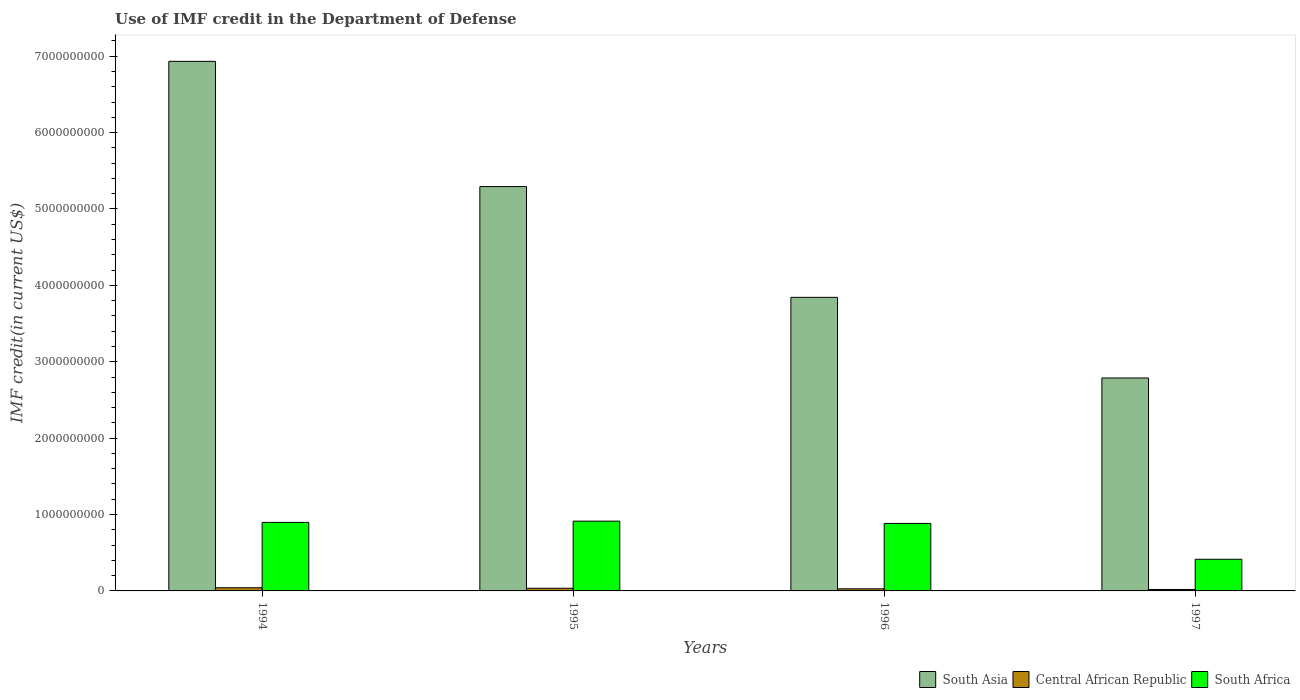How many groups of bars are there?
Make the answer very short. 4. Are the number of bars on each tick of the X-axis equal?
Your response must be concise. Yes. How many bars are there on the 2nd tick from the left?
Ensure brevity in your answer.  3. What is the IMF credit in the Department of Defense in Central African Republic in 1994?
Give a very brief answer. 4.14e+07. Across all years, what is the maximum IMF credit in the Department of Defense in South Africa?
Give a very brief answer. 9.13e+08. Across all years, what is the minimum IMF credit in the Department of Defense in Central African Republic?
Give a very brief answer. 1.86e+07. In which year was the IMF credit in the Department of Defense in South Asia maximum?
Offer a very short reply. 1994. In which year was the IMF credit in the Department of Defense in Central African Republic minimum?
Make the answer very short. 1997. What is the total IMF credit in the Department of Defense in South Asia in the graph?
Your answer should be compact. 1.89e+1. What is the difference between the IMF credit in the Department of Defense in Central African Republic in 1996 and that in 1997?
Keep it short and to the point. 9.02e+06. What is the difference between the IMF credit in the Department of Defense in Central African Republic in 1994 and the IMF credit in the Department of Defense in South Asia in 1995?
Make the answer very short. -5.25e+09. What is the average IMF credit in the Department of Defense in South Africa per year?
Your answer should be compact. 7.77e+08. In the year 1995, what is the difference between the IMF credit in the Department of Defense in Central African Republic and IMF credit in the Department of Defense in South Africa?
Offer a very short reply. -8.78e+08. In how many years, is the IMF credit in the Department of Defense in South Asia greater than 600000000 US$?
Offer a very short reply. 4. What is the ratio of the IMF credit in the Department of Defense in South Asia in 1994 to that in 1996?
Provide a succinct answer. 1.8. Is the IMF credit in the Department of Defense in South Africa in 1994 less than that in 1997?
Give a very brief answer. No. What is the difference between the highest and the second highest IMF credit in the Department of Defense in South Asia?
Ensure brevity in your answer.  1.64e+09. What is the difference between the highest and the lowest IMF credit in the Department of Defense in South Asia?
Your answer should be compact. 4.14e+09. In how many years, is the IMF credit in the Department of Defense in South Asia greater than the average IMF credit in the Department of Defense in South Asia taken over all years?
Ensure brevity in your answer.  2. What does the 2nd bar from the left in 1995 represents?
Provide a succinct answer. Central African Republic. What does the 2nd bar from the right in 1994 represents?
Provide a succinct answer. Central African Republic. Are all the bars in the graph horizontal?
Provide a succinct answer. No. Does the graph contain any zero values?
Ensure brevity in your answer.  No. Where does the legend appear in the graph?
Provide a short and direct response. Bottom right. What is the title of the graph?
Give a very brief answer. Use of IMF credit in the Department of Defense. Does "Tajikistan" appear as one of the legend labels in the graph?
Your answer should be very brief. No. What is the label or title of the X-axis?
Give a very brief answer. Years. What is the label or title of the Y-axis?
Give a very brief answer. IMF credit(in current US$). What is the IMF credit(in current US$) of South Asia in 1994?
Offer a very short reply. 6.93e+09. What is the IMF credit(in current US$) of Central African Republic in 1994?
Make the answer very short. 4.14e+07. What is the IMF credit(in current US$) of South Africa in 1994?
Offer a very short reply. 8.97e+08. What is the IMF credit(in current US$) of South Asia in 1995?
Make the answer very short. 5.29e+09. What is the IMF credit(in current US$) in Central African Republic in 1995?
Provide a succinct answer. 3.49e+07. What is the IMF credit(in current US$) of South Africa in 1995?
Offer a terse response. 9.13e+08. What is the IMF credit(in current US$) of South Asia in 1996?
Provide a short and direct response. 3.84e+09. What is the IMF credit(in current US$) of Central African Republic in 1996?
Offer a very short reply. 2.76e+07. What is the IMF credit(in current US$) in South Africa in 1996?
Make the answer very short. 8.84e+08. What is the IMF credit(in current US$) of South Asia in 1997?
Ensure brevity in your answer.  2.79e+09. What is the IMF credit(in current US$) in Central African Republic in 1997?
Provide a succinct answer. 1.86e+07. What is the IMF credit(in current US$) of South Africa in 1997?
Provide a short and direct response. 4.15e+08. Across all years, what is the maximum IMF credit(in current US$) of South Asia?
Provide a short and direct response. 6.93e+09. Across all years, what is the maximum IMF credit(in current US$) in Central African Republic?
Offer a very short reply. 4.14e+07. Across all years, what is the maximum IMF credit(in current US$) of South Africa?
Keep it short and to the point. 9.13e+08. Across all years, what is the minimum IMF credit(in current US$) of South Asia?
Offer a very short reply. 2.79e+09. Across all years, what is the minimum IMF credit(in current US$) of Central African Republic?
Your answer should be compact. 1.86e+07. Across all years, what is the minimum IMF credit(in current US$) in South Africa?
Provide a succinct answer. 4.15e+08. What is the total IMF credit(in current US$) of South Asia in the graph?
Offer a very short reply. 1.89e+1. What is the total IMF credit(in current US$) in Central African Republic in the graph?
Your answer should be very brief. 1.23e+08. What is the total IMF credit(in current US$) in South Africa in the graph?
Make the answer very short. 3.11e+09. What is the difference between the IMF credit(in current US$) of South Asia in 1994 and that in 1995?
Give a very brief answer. 1.64e+09. What is the difference between the IMF credit(in current US$) of Central African Republic in 1994 and that in 1995?
Make the answer very short. 6.47e+06. What is the difference between the IMF credit(in current US$) in South Africa in 1994 and that in 1995?
Provide a short and direct response. -1.64e+07. What is the difference between the IMF credit(in current US$) of South Asia in 1994 and that in 1996?
Keep it short and to the point. 3.09e+09. What is the difference between the IMF credit(in current US$) of Central African Republic in 1994 and that in 1996?
Provide a short and direct response. 1.37e+07. What is the difference between the IMF credit(in current US$) of South Africa in 1994 and that in 1996?
Offer a very short reply. 1.34e+07. What is the difference between the IMF credit(in current US$) in South Asia in 1994 and that in 1997?
Your answer should be very brief. 4.14e+09. What is the difference between the IMF credit(in current US$) in Central African Republic in 1994 and that in 1997?
Ensure brevity in your answer.  2.28e+07. What is the difference between the IMF credit(in current US$) in South Africa in 1994 and that in 1997?
Your answer should be very brief. 4.82e+08. What is the difference between the IMF credit(in current US$) of South Asia in 1995 and that in 1996?
Your response must be concise. 1.45e+09. What is the difference between the IMF credit(in current US$) in Central African Republic in 1995 and that in 1996?
Ensure brevity in your answer.  7.26e+06. What is the difference between the IMF credit(in current US$) of South Africa in 1995 and that in 1996?
Give a very brief answer. 2.98e+07. What is the difference between the IMF credit(in current US$) of South Asia in 1995 and that in 1997?
Make the answer very short. 2.51e+09. What is the difference between the IMF credit(in current US$) of Central African Republic in 1995 and that in 1997?
Your answer should be very brief. 1.63e+07. What is the difference between the IMF credit(in current US$) in South Africa in 1995 and that in 1997?
Offer a terse response. 4.99e+08. What is the difference between the IMF credit(in current US$) in South Asia in 1996 and that in 1997?
Your answer should be very brief. 1.06e+09. What is the difference between the IMF credit(in current US$) of Central African Republic in 1996 and that in 1997?
Provide a succinct answer. 9.02e+06. What is the difference between the IMF credit(in current US$) in South Africa in 1996 and that in 1997?
Offer a terse response. 4.69e+08. What is the difference between the IMF credit(in current US$) in South Asia in 1994 and the IMF credit(in current US$) in Central African Republic in 1995?
Your answer should be very brief. 6.90e+09. What is the difference between the IMF credit(in current US$) in South Asia in 1994 and the IMF credit(in current US$) in South Africa in 1995?
Ensure brevity in your answer.  6.02e+09. What is the difference between the IMF credit(in current US$) in Central African Republic in 1994 and the IMF credit(in current US$) in South Africa in 1995?
Keep it short and to the point. -8.72e+08. What is the difference between the IMF credit(in current US$) of South Asia in 1994 and the IMF credit(in current US$) of Central African Republic in 1996?
Your answer should be compact. 6.90e+09. What is the difference between the IMF credit(in current US$) of South Asia in 1994 and the IMF credit(in current US$) of South Africa in 1996?
Provide a succinct answer. 6.05e+09. What is the difference between the IMF credit(in current US$) of Central African Republic in 1994 and the IMF credit(in current US$) of South Africa in 1996?
Keep it short and to the point. -8.42e+08. What is the difference between the IMF credit(in current US$) in South Asia in 1994 and the IMF credit(in current US$) in Central African Republic in 1997?
Offer a terse response. 6.91e+09. What is the difference between the IMF credit(in current US$) of South Asia in 1994 and the IMF credit(in current US$) of South Africa in 1997?
Provide a succinct answer. 6.52e+09. What is the difference between the IMF credit(in current US$) in Central African Republic in 1994 and the IMF credit(in current US$) in South Africa in 1997?
Your answer should be compact. -3.73e+08. What is the difference between the IMF credit(in current US$) in South Asia in 1995 and the IMF credit(in current US$) in Central African Republic in 1996?
Offer a terse response. 5.27e+09. What is the difference between the IMF credit(in current US$) of South Asia in 1995 and the IMF credit(in current US$) of South Africa in 1996?
Ensure brevity in your answer.  4.41e+09. What is the difference between the IMF credit(in current US$) of Central African Republic in 1995 and the IMF credit(in current US$) of South Africa in 1996?
Your answer should be very brief. -8.49e+08. What is the difference between the IMF credit(in current US$) of South Asia in 1995 and the IMF credit(in current US$) of Central African Republic in 1997?
Ensure brevity in your answer.  5.27e+09. What is the difference between the IMF credit(in current US$) of South Asia in 1995 and the IMF credit(in current US$) of South Africa in 1997?
Provide a succinct answer. 4.88e+09. What is the difference between the IMF credit(in current US$) in Central African Republic in 1995 and the IMF credit(in current US$) in South Africa in 1997?
Make the answer very short. -3.80e+08. What is the difference between the IMF credit(in current US$) of South Asia in 1996 and the IMF credit(in current US$) of Central African Republic in 1997?
Make the answer very short. 3.82e+09. What is the difference between the IMF credit(in current US$) of South Asia in 1996 and the IMF credit(in current US$) of South Africa in 1997?
Provide a succinct answer. 3.43e+09. What is the difference between the IMF credit(in current US$) in Central African Republic in 1996 and the IMF credit(in current US$) in South Africa in 1997?
Give a very brief answer. -3.87e+08. What is the average IMF credit(in current US$) of South Asia per year?
Ensure brevity in your answer.  4.71e+09. What is the average IMF credit(in current US$) of Central African Republic per year?
Offer a terse response. 3.06e+07. What is the average IMF credit(in current US$) in South Africa per year?
Give a very brief answer. 7.77e+08. In the year 1994, what is the difference between the IMF credit(in current US$) of South Asia and IMF credit(in current US$) of Central African Republic?
Offer a terse response. 6.89e+09. In the year 1994, what is the difference between the IMF credit(in current US$) of South Asia and IMF credit(in current US$) of South Africa?
Your answer should be very brief. 6.04e+09. In the year 1994, what is the difference between the IMF credit(in current US$) of Central African Republic and IMF credit(in current US$) of South Africa?
Offer a terse response. -8.56e+08. In the year 1995, what is the difference between the IMF credit(in current US$) in South Asia and IMF credit(in current US$) in Central African Republic?
Provide a succinct answer. 5.26e+09. In the year 1995, what is the difference between the IMF credit(in current US$) in South Asia and IMF credit(in current US$) in South Africa?
Keep it short and to the point. 4.38e+09. In the year 1995, what is the difference between the IMF credit(in current US$) of Central African Republic and IMF credit(in current US$) of South Africa?
Your answer should be compact. -8.78e+08. In the year 1996, what is the difference between the IMF credit(in current US$) in South Asia and IMF credit(in current US$) in Central African Republic?
Offer a terse response. 3.82e+09. In the year 1996, what is the difference between the IMF credit(in current US$) in South Asia and IMF credit(in current US$) in South Africa?
Provide a short and direct response. 2.96e+09. In the year 1996, what is the difference between the IMF credit(in current US$) of Central African Republic and IMF credit(in current US$) of South Africa?
Your answer should be very brief. -8.56e+08. In the year 1997, what is the difference between the IMF credit(in current US$) of South Asia and IMF credit(in current US$) of Central African Republic?
Keep it short and to the point. 2.77e+09. In the year 1997, what is the difference between the IMF credit(in current US$) in South Asia and IMF credit(in current US$) in South Africa?
Provide a short and direct response. 2.37e+09. In the year 1997, what is the difference between the IMF credit(in current US$) of Central African Republic and IMF credit(in current US$) of South Africa?
Your response must be concise. -3.96e+08. What is the ratio of the IMF credit(in current US$) in South Asia in 1994 to that in 1995?
Offer a terse response. 1.31. What is the ratio of the IMF credit(in current US$) in Central African Republic in 1994 to that in 1995?
Ensure brevity in your answer.  1.19. What is the ratio of the IMF credit(in current US$) in South Africa in 1994 to that in 1995?
Ensure brevity in your answer.  0.98. What is the ratio of the IMF credit(in current US$) of South Asia in 1994 to that in 1996?
Give a very brief answer. 1.8. What is the ratio of the IMF credit(in current US$) in Central African Republic in 1994 to that in 1996?
Make the answer very short. 1.5. What is the ratio of the IMF credit(in current US$) of South Africa in 1994 to that in 1996?
Provide a succinct answer. 1.02. What is the ratio of the IMF credit(in current US$) of South Asia in 1994 to that in 1997?
Ensure brevity in your answer.  2.49. What is the ratio of the IMF credit(in current US$) in Central African Republic in 1994 to that in 1997?
Offer a terse response. 2.22. What is the ratio of the IMF credit(in current US$) in South Africa in 1994 to that in 1997?
Make the answer very short. 2.16. What is the ratio of the IMF credit(in current US$) of South Asia in 1995 to that in 1996?
Offer a terse response. 1.38. What is the ratio of the IMF credit(in current US$) in Central African Republic in 1995 to that in 1996?
Provide a short and direct response. 1.26. What is the ratio of the IMF credit(in current US$) of South Africa in 1995 to that in 1996?
Provide a succinct answer. 1.03. What is the ratio of the IMF credit(in current US$) in South Asia in 1995 to that in 1997?
Keep it short and to the point. 1.9. What is the ratio of the IMF credit(in current US$) in Central African Republic in 1995 to that in 1997?
Provide a succinct answer. 1.87. What is the ratio of the IMF credit(in current US$) in South Africa in 1995 to that in 1997?
Offer a terse response. 2.2. What is the ratio of the IMF credit(in current US$) in South Asia in 1996 to that in 1997?
Make the answer very short. 1.38. What is the ratio of the IMF credit(in current US$) in Central African Republic in 1996 to that in 1997?
Ensure brevity in your answer.  1.48. What is the ratio of the IMF credit(in current US$) in South Africa in 1996 to that in 1997?
Your response must be concise. 2.13. What is the difference between the highest and the second highest IMF credit(in current US$) of South Asia?
Your response must be concise. 1.64e+09. What is the difference between the highest and the second highest IMF credit(in current US$) of Central African Republic?
Offer a terse response. 6.47e+06. What is the difference between the highest and the second highest IMF credit(in current US$) of South Africa?
Provide a short and direct response. 1.64e+07. What is the difference between the highest and the lowest IMF credit(in current US$) in South Asia?
Offer a very short reply. 4.14e+09. What is the difference between the highest and the lowest IMF credit(in current US$) of Central African Republic?
Your response must be concise. 2.28e+07. What is the difference between the highest and the lowest IMF credit(in current US$) of South Africa?
Ensure brevity in your answer.  4.99e+08. 